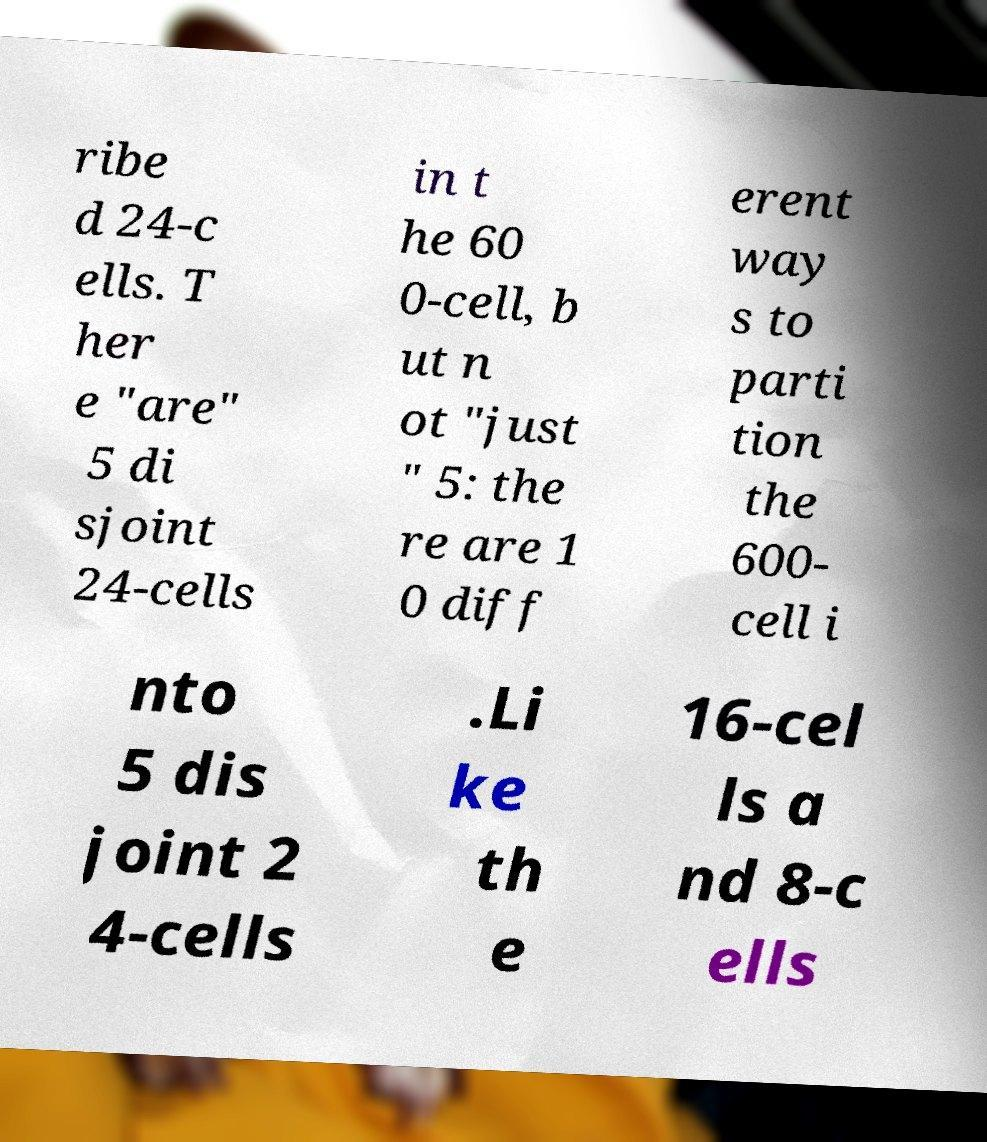I need the written content from this picture converted into text. Can you do that? ribe d 24-c ells. T her e "are" 5 di sjoint 24-cells in t he 60 0-cell, b ut n ot "just " 5: the re are 1 0 diff erent way s to parti tion the 600- cell i nto 5 dis joint 2 4-cells .Li ke th e 16-cel ls a nd 8-c ells 